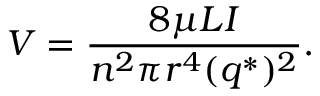Convert formula to latex. <formula><loc_0><loc_0><loc_500><loc_500>V = { \frac { 8 \mu L I } { n ^ { 2 } \pi r ^ { 4 } ( q ^ { * } ) ^ { 2 } } } .</formula> 